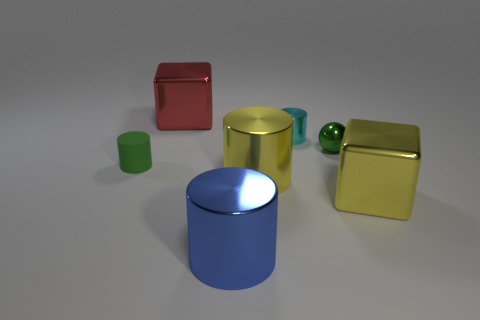Is there any other thing that has the same material as the tiny green cylinder?
Offer a very short reply. No. Is the number of big red objects right of the red shiny block greater than the number of big brown cylinders?
Provide a short and direct response. No. What number of rubber things are large red blocks or tiny cyan cubes?
Provide a succinct answer. 0. There is a shiny thing that is left of the yellow cylinder and right of the big red shiny object; what is its size?
Provide a succinct answer. Large. There is a yellow metal object that is on the right side of the tiny cyan object; are there any big blue metal cylinders in front of it?
Keep it short and to the point. Yes. There is a red metallic thing; how many green objects are behind it?
Your response must be concise. 0. The other rubber thing that is the same shape as the cyan thing is what color?
Keep it short and to the point. Green. Are the big block behind the tiny cyan metallic cylinder and the tiny thing that is in front of the shiny ball made of the same material?
Ensure brevity in your answer.  No. There is a small rubber cylinder; does it have the same color as the shiny cube that is on the right side of the red metallic cube?
Ensure brevity in your answer.  No. There is a metal object that is both to the right of the blue thing and behind the small sphere; what shape is it?
Your response must be concise. Cylinder. 